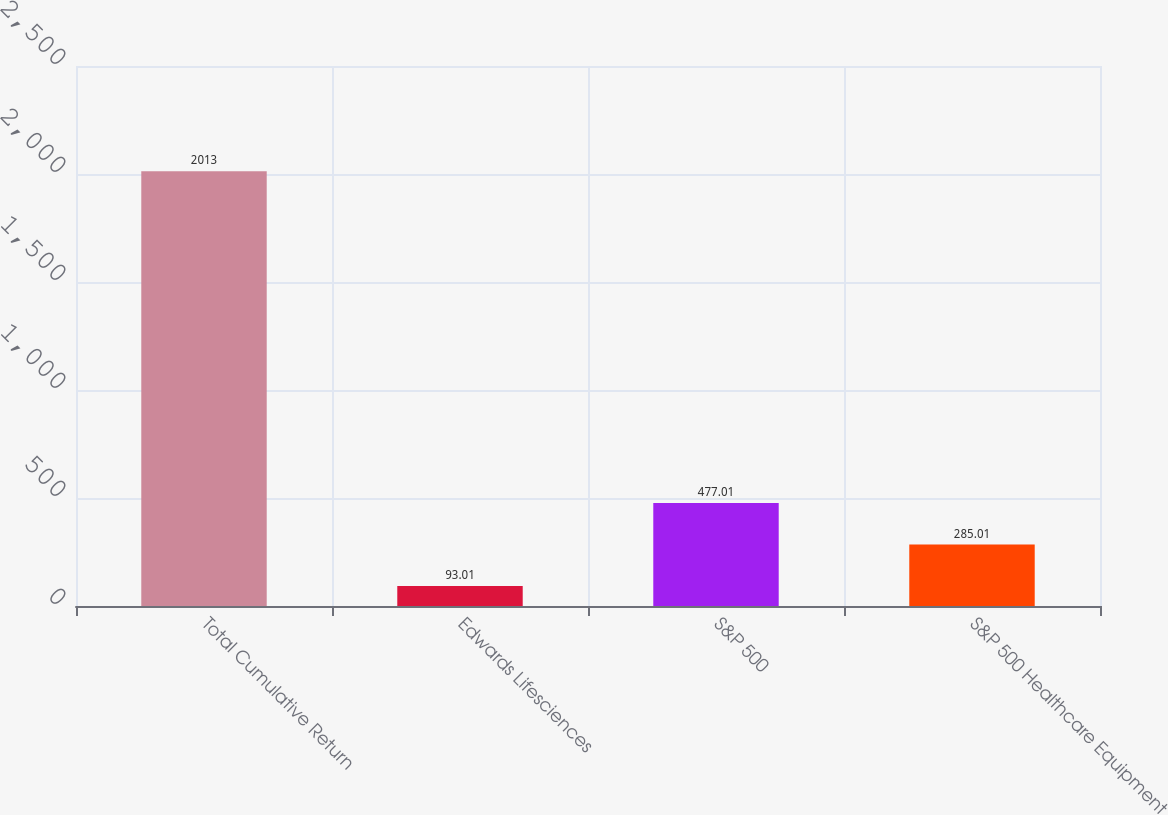Convert chart to OTSL. <chart><loc_0><loc_0><loc_500><loc_500><bar_chart><fcel>Total Cumulative Return<fcel>Edwards Lifesciences<fcel>S&P 500<fcel>S&P 500 Healthcare Equipment<nl><fcel>2013<fcel>93.01<fcel>477.01<fcel>285.01<nl></chart> 